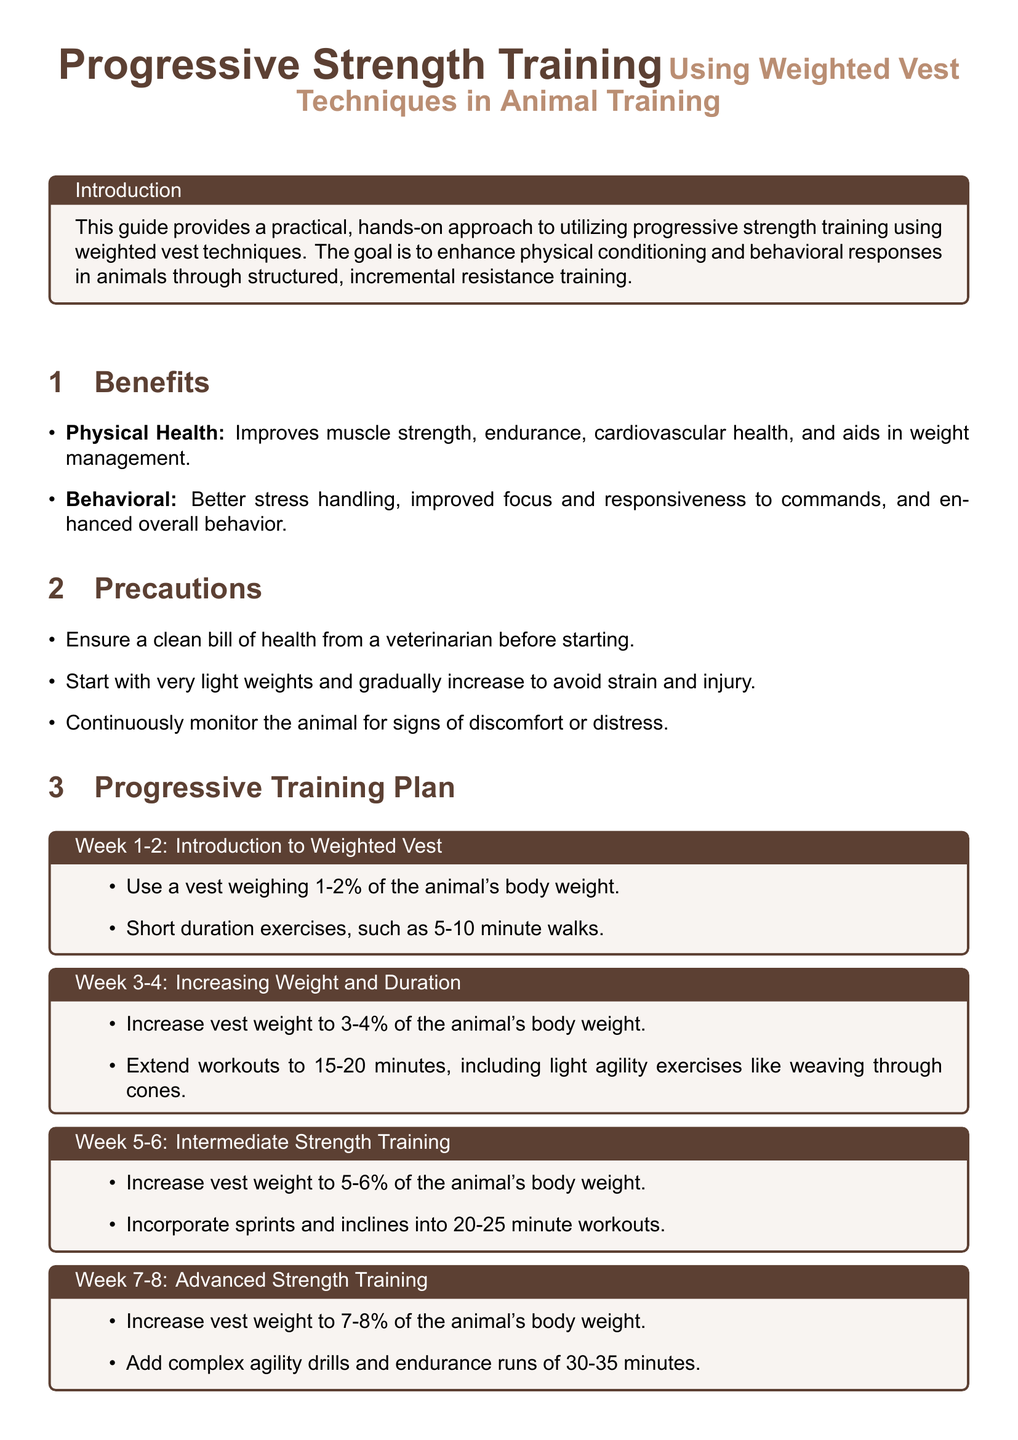what is the main goal of the guide? The main goal is to enhance physical conditioning and behavioral responses in animals through structured, incremental resistance training.
Answer: enhance physical conditioning and behavioral responses what percentage of the animal's body weight should the vest weigh in Week 1-2? In Week 1-2, the vest should weigh 1-2% of the animal's body weight.
Answer: 1-2% what type of exercises are recommended in Weeks 5-6? The document recommends incorporating sprints and inclines into the workouts during Weeks 5-6.
Answer: sprints and inclines how long should workouts be during Weeks 7-8? Workouts during Weeks 7-8 should last 30-35 minutes.
Answer: 30-35 minutes what is a benefit of using weighted vests in animal training? A benefit is improved muscle strength.
Answer: improved muscle strength what should be continuously monitored during training? The animal should be continuously monitored for signs of discomfort or distress.
Answer: discomfort or distress what is the weight of the vest in Weeks 3-4? In Weeks 3-4, the vest weight should be increased to 3-4% of the animal's body weight.
Answer: 3-4% which type of animals does the document provide examples for? The document provides examples for dogs and horses.
Answer: dogs and horses 